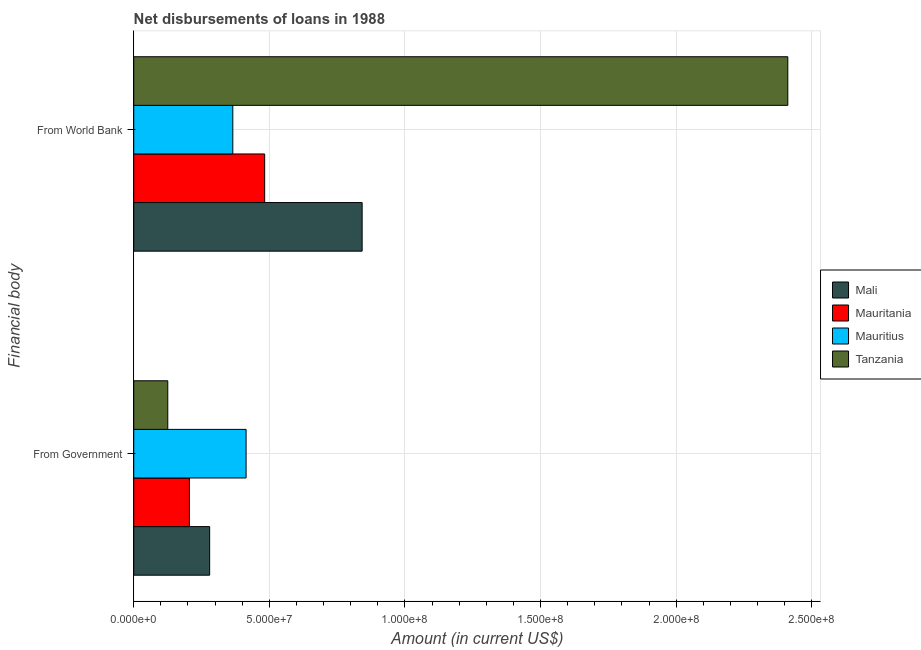How many groups of bars are there?
Keep it short and to the point. 2. Are the number of bars per tick equal to the number of legend labels?
Keep it short and to the point. Yes. How many bars are there on the 2nd tick from the top?
Your answer should be very brief. 4. What is the label of the 1st group of bars from the top?
Offer a terse response. From World Bank. What is the net disbursements of loan from government in Tanzania?
Offer a very short reply. 1.25e+07. Across all countries, what is the maximum net disbursements of loan from world bank?
Your response must be concise. 2.41e+08. Across all countries, what is the minimum net disbursements of loan from world bank?
Your answer should be very brief. 3.65e+07. In which country was the net disbursements of loan from world bank maximum?
Keep it short and to the point. Tanzania. In which country was the net disbursements of loan from world bank minimum?
Your answer should be compact. Mauritius. What is the total net disbursements of loan from government in the graph?
Keep it short and to the point. 1.02e+08. What is the difference between the net disbursements of loan from government in Mauritius and that in Mauritania?
Make the answer very short. 2.09e+07. What is the difference between the net disbursements of loan from government in Mauritania and the net disbursements of loan from world bank in Mali?
Offer a terse response. -6.37e+07. What is the average net disbursements of loan from government per country?
Make the answer very short. 2.56e+07. What is the difference between the net disbursements of loan from government and net disbursements of loan from world bank in Mauritius?
Offer a very short reply. 4.90e+06. What is the ratio of the net disbursements of loan from government in Mauritania to that in Tanzania?
Your response must be concise. 1.64. What does the 1st bar from the top in From Government represents?
Offer a very short reply. Tanzania. What does the 4th bar from the bottom in From Government represents?
Keep it short and to the point. Tanzania. How many bars are there?
Keep it short and to the point. 8. What is the difference between two consecutive major ticks on the X-axis?
Make the answer very short. 5.00e+07. Are the values on the major ticks of X-axis written in scientific E-notation?
Offer a very short reply. Yes. Does the graph contain any zero values?
Ensure brevity in your answer.  No. Does the graph contain grids?
Your response must be concise. Yes. Where does the legend appear in the graph?
Offer a very short reply. Center right. What is the title of the graph?
Offer a very short reply. Net disbursements of loans in 1988. Does "Iraq" appear as one of the legend labels in the graph?
Give a very brief answer. No. What is the label or title of the Y-axis?
Give a very brief answer. Financial body. What is the Amount (in current US$) of Mali in From Government?
Keep it short and to the point. 2.80e+07. What is the Amount (in current US$) in Mauritania in From Government?
Keep it short and to the point. 2.05e+07. What is the Amount (in current US$) of Mauritius in From Government?
Provide a succinct answer. 4.14e+07. What is the Amount (in current US$) in Tanzania in From Government?
Provide a short and direct response. 1.25e+07. What is the Amount (in current US$) in Mali in From World Bank?
Provide a succinct answer. 8.42e+07. What is the Amount (in current US$) in Mauritania in From World Bank?
Offer a terse response. 4.83e+07. What is the Amount (in current US$) of Mauritius in From World Bank?
Ensure brevity in your answer.  3.65e+07. What is the Amount (in current US$) of Tanzania in From World Bank?
Provide a short and direct response. 2.41e+08. Across all Financial body, what is the maximum Amount (in current US$) in Mali?
Give a very brief answer. 8.42e+07. Across all Financial body, what is the maximum Amount (in current US$) in Mauritania?
Ensure brevity in your answer.  4.83e+07. Across all Financial body, what is the maximum Amount (in current US$) of Mauritius?
Provide a short and direct response. 4.14e+07. Across all Financial body, what is the maximum Amount (in current US$) in Tanzania?
Offer a terse response. 2.41e+08. Across all Financial body, what is the minimum Amount (in current US$) in Mali?
Keep it short and to the point. 2.80e+07. Across all Financial body, what is the minimum Amount (in current US$) of Mauritania?
Keep it short and to the point. 2.05e+07. Across all Financial body, what is the minimum Amount (in current US$) in Mauritius?
Your response must be concise. 3.65e+07. Across all Financial body, what is the minimum Amount (in current US$) in Tanzania?
Your answer should be compact. 1.25e+07. What is the total Amount (in current US$) in Mali in the graph?
Provide a short and direct response. 1.12e+08. What is the total Amount (in current US$) in Mauritania in the graph?
Your answer should be very brief. 6.88e+07. What is the total Amount (in current US$) of Mauritius in the graph?
Provide a short and direct response. 7.79e+07. What is the total Amount (in current US$) of Tanzania in the graph?
Make the answer very short. 2.54e+08. What is the difference between the Amount (in current US$) in Mali in From Government and that in From World Bank?
Keep it short and to the point. -5.62e+07. What is the difference between the Amount (in current US$) in Mauritania in From Government and that in From World Bank?
Your response must be concise. -2.78e+07. What is the difference between the Amount (in current US$) of Mauritius in From Government and that in From World Bank?
Offer a terse response. 4.90e+06. What is the difference between the Amount (in current US$) in Tanzania in From Government and that in From World Bank?
Offer a very short reply. -2.29e+08. What is the difference between the Amount (in current US$) in Mali in From Government and the Amount (in current US$) in Mauritania in From World Bank?
Provide a short and direct response. -2.03e+07. What is the difference between the Amount (in current US$) in Mali in From Government and the Amount (in current US$) in Mauritius in From World Bank?
Give a very brief answer. -8.54e+06. What is the difference between the Amount (in current US$) of Mali in From Government and the Amount (in current US$) of Tanzania in From World Bank?
Keep it short and to the point. -2.13e+08. What is the difference between the Amount (in current US$) in Mauritania in From Government and the Amount (in current US$) in Mauritius in From World Bank?
Offer a very short reply. -1.60e+07. What is the difference between the Amount (in current US$) of Mauritania in From Government and the Amount (in current US$) of Tanzania in From World Bank?
Offer a terse response. -2.21e+08. What is the difference between the Amount (in current US$) in Mauritius in From Government and the Amount (in current US$) in Tanzania in From World Bank?
Offer a very short reply. -2.00e+08. What is the average Amount (in current US$) of Mali per Financial body?
Make the answer very short. 5.61e+07. What is the average Amount (in current US$) of Mauritania per Financial body?
Keep it short and to the point. 3.44e+07. What is the average Amount (in current US$) in Mauritius per Financial body?
Offer a terse response. 3.90e+07. What is the average Amount (in current US$) of Tanzania per Financial body?
Offer a very short reply. 1.27e+08. What is the difference between the Amount (in current US$) in Mali and Amount (in current US$) in Mauritania in From Government?
Your answer should be very brief. 7.46e+06. What is the difference between the Amount (in current US$) in Mali and Amount (in current US$) in Mauritius in From Government?
Ensure brevity in your answer.  -1.34e+07. What is the difference between the Amount (in current US$) of Mali and Amount (in current US$) of Tanzania in From Government?
Your answer should be compact. 1.54e+07. What is the difference between the Amount (in current US$) in Mauritania and Amount (in current US$) in Mauritius in From Government?
Your answer should be compact. -2.09e+07. What is the difference between the Amount (in current US$) of Mauritania and Amount (in current US$) of Tanzania in From Government?
Give a very brief answer. 7.98e+06. What is the difference between the Amount (in current US$) of Mauritius and Amount (in current US$) of Tanzania in From Government?
Your answer should be very brief. 2.89e+07. What is the difference between the Amount (in current US$) of Mali and Amount (in current US$) of Mauritania in From World Bank?
Offer a terse response. 3.59e+07. What is the difference between the Amount (in current US$) in Mali and Amount (in current US$) in Mauritius in From World Bank?
Your response must be concise. 4.77e+07. What is the difference between the Amount (in current US$) of Mali and Amount (in current US$) of Tanzania in From World Bank?
Offer a very short reply. -1.57e+08. What is the difference between the Amount (in current US$) in Mauritania and Amount (in current US$) in Mauritius in From World Bank?
Provide a short and direct response. 1.17e+07. What is the difference between the Amount (in current US$) of Mauritania and Amount (in current US$) of Tanzania in From World Bank?
Your answer should be compact. -1.93e+08. What is the difference between the Amount (in current US$) in Mauritius and Amount (in current US$) in Tanzania in From World Bank?
Your answer should be compact. -2.05e+08. What is the ratio of the Amount (in current US$) of Mali in From Government to that in From World Bank?
Provide a short and direct response. 0.33. What is the ratio of the Amount (in current US$) in Mauritania in From Government to that in From World Bank?
Make the answer very short. 0.43. What is the ratio of the Amount (in current US$) in Mauritius in From Government to that in From World Bank?
Offer a very short reply. 1.13. What is the ratio of the Amount (in current US$) of Tanzania in From Government to that in From World Bank?
Your answer should be compact. 0.05. What is the difference between the highest and the second highest Amount (in current US$) of Mali?
Provide a succinct answer. 5.62e+07. What is the difference between the highest and the second highest Amount (in current US$) of Mauritania?
Ensure brevity in your answer.  2.78e+07. What is the difference between the highest and the second highest Amount (in current US$) of Mauritius?
Offer a very short reply. 4.90e+06. What is the difference between the highest and the second highest Amount (in current US$) of Tanzania?
Give a very brief answer. 2.29e+08. What is the difference between the highest and the lowest Amount (in current US$) of Mali?
Make the answer very short. 5.62e+07. What is the difference between the highest and the lowest Amount (in current US$) of Mauritania?
Offer a very short reply. 2.78e+07. What is the difference between the highest and the lowest Amount (in current US$) in Mauritius?
Ensure brevity in your answer.  4.90e+06. What is the difference between the highest and the lowest Amount (in current US$) in Tanzania?
Your answer should be very brief. 2.29e+08. 